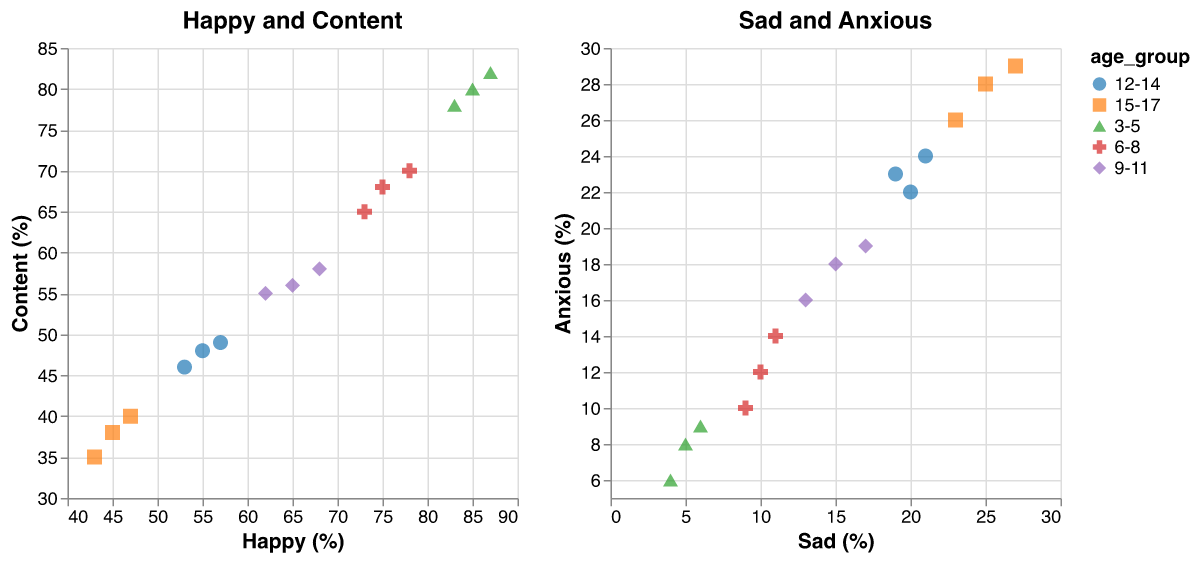Which age group reports the highest percentage of being happy? By looking at the scatter plot for 'Happy and Content', the age group '3-5' has the highest reported percentage of being happy. One of the points has a value of 87% happiness, which is the highest among all points.
Answer: 3-5 How do the percentages of 'happy' and 'content' emotions vary across different age groups? Observing the 'Happy and Content' scatter plot, the percentage of being happy and content decreases as the age group increases. The younger age group (3-5) reports the highest percentages for both happy and content, while the older age group (15-17) reports the lowest.
Answer: Happy and content percentages decrease with age What is the maximum percentage of being content reported by the 9-11 age group? From the 'Happy and Content' subplot, the highest percentage of being content for the age group 9-11 is shown to be 58%. This value is visible among the data points for the age group 9-11.
Answer: 58% Which age group has the highest average percentage of anxious emotions? To find the answer, average the 'percentage_anxious' values for each age group. Upon calculation, the age group '15-17' has the highest average percentage of being anxious compared to other age groups.
Answer: 15-17 For age group 3-5, what is the average happiness percentage reported in the surveys? For age group 3-5, add the reported happiness percentages (85 + 83 + 87) and divide by the number of data points (3). The average happiness percentage is (85 + 83 + 87) / 3 = 85%.
Answer: 85% Compare the percentage of sad emotions between the age groups 12-14 and 15-17. Which group reports a higher percentage? By comparing data points in the 'Sad and Anxious' subplot, the age group 15-17 reports higher percentages of sadness (23-27%) than the age group 12-14 (19-21%).
Answer: 15-17 How does the correlation between 'happy' and 'content' emotions differ among the age groups? In the 'Happy and Content' subplot, younger age groups (3-5 and 6-8) show a high and positive correlation between happy and content emotions. This correlation weakens as the age group gets older (9-11, 12-14, 15-17), indicating less contentment as happiness decreases.
Answer: Correlation weakens with age What is the range of 'anxious' percentages for the age group 6-8? The 'percentage_anxious' for age group 6-8 varies from 10% to 14% as seen in the 'Sad and Anxious' subplot, and the smallest value is 10%, while the highest is 14%.
Answer: 10% - 14% Compare the 'sad' percentages between age groups 9-11 and 12-14. Which age group experiences a higher percentage on average? Adding up the sad percentages and dividing by the number of data points for each age group: 9-11 (15+13+17)/3 = 15%, and 12-14 (20+21+19)/3 = 20%. The age group 12-14 experiences a higher average 'sad' percentage.
Answer: 12-14 